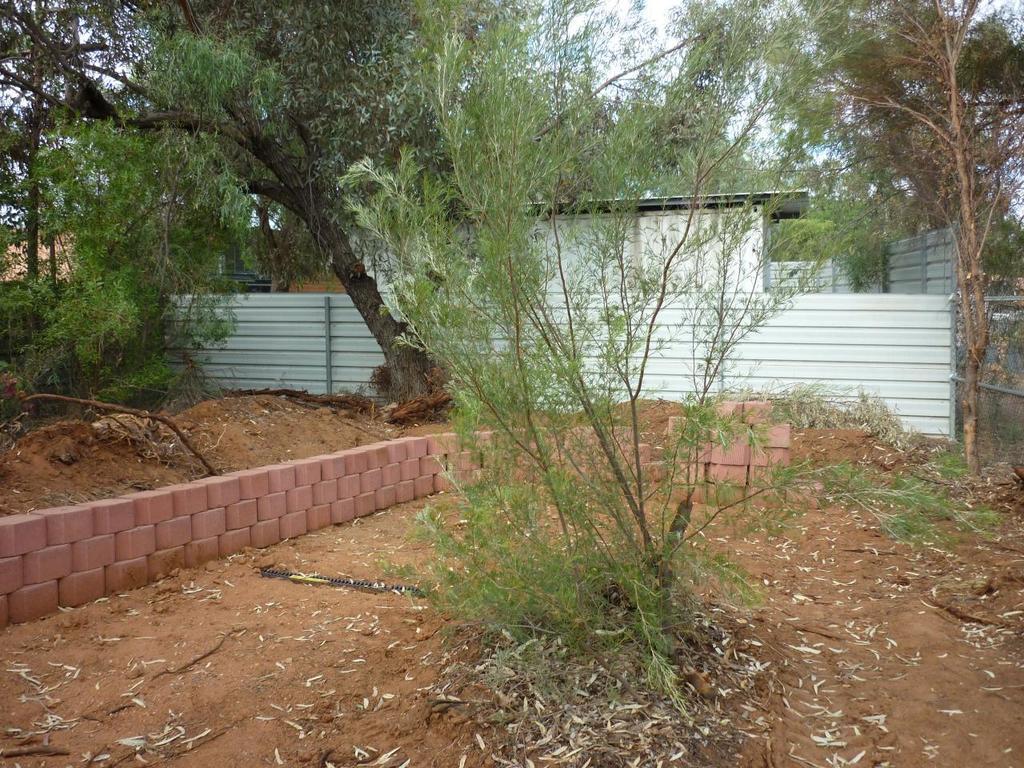Describe this image in one or two sentences. In this image we can see some plants, a wall with bricks, a metal fence, a building, a group of trees and the sky which looks cloudy. 